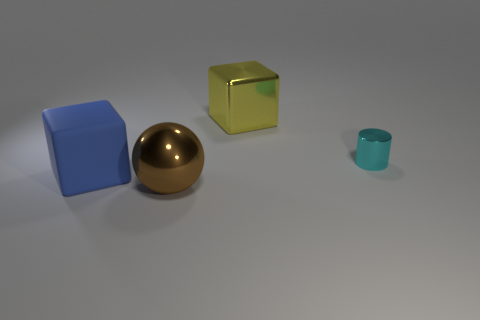Are there more big blue rubber objects on the right side of the blue object than tiny shiny objects?
Offer a very short reply. No. The blue thing that is the same shape as the yellow object is what size?
Provide a short and direct response. Large. Is there anything else that is the same material as the blue cube?
Offer a very short reply. No. There is a cyan metal thing; what shape is it?
Provide a succinct answer. Cylinder. There is a yellow thing that is the same size as the blue matte object; what is its shape?
Provide a succinct answer. Cube. Is there anything else that has the same color as the cylinder?
Ensure brevity in your answer.  No. There is a cube that is the same material as the cylinder; what size is it?
Your answer should be very brief. Large. There is a cyan object; is its shape the same as the big thing right of the ball?
Your answer should be very brief. No. How big is the blue cube?
Keep it short and to the point. Large. Is the number of small objects that are in front of the big blue matte object less than the number of cubes?
Offer a very short reply. Yes. 